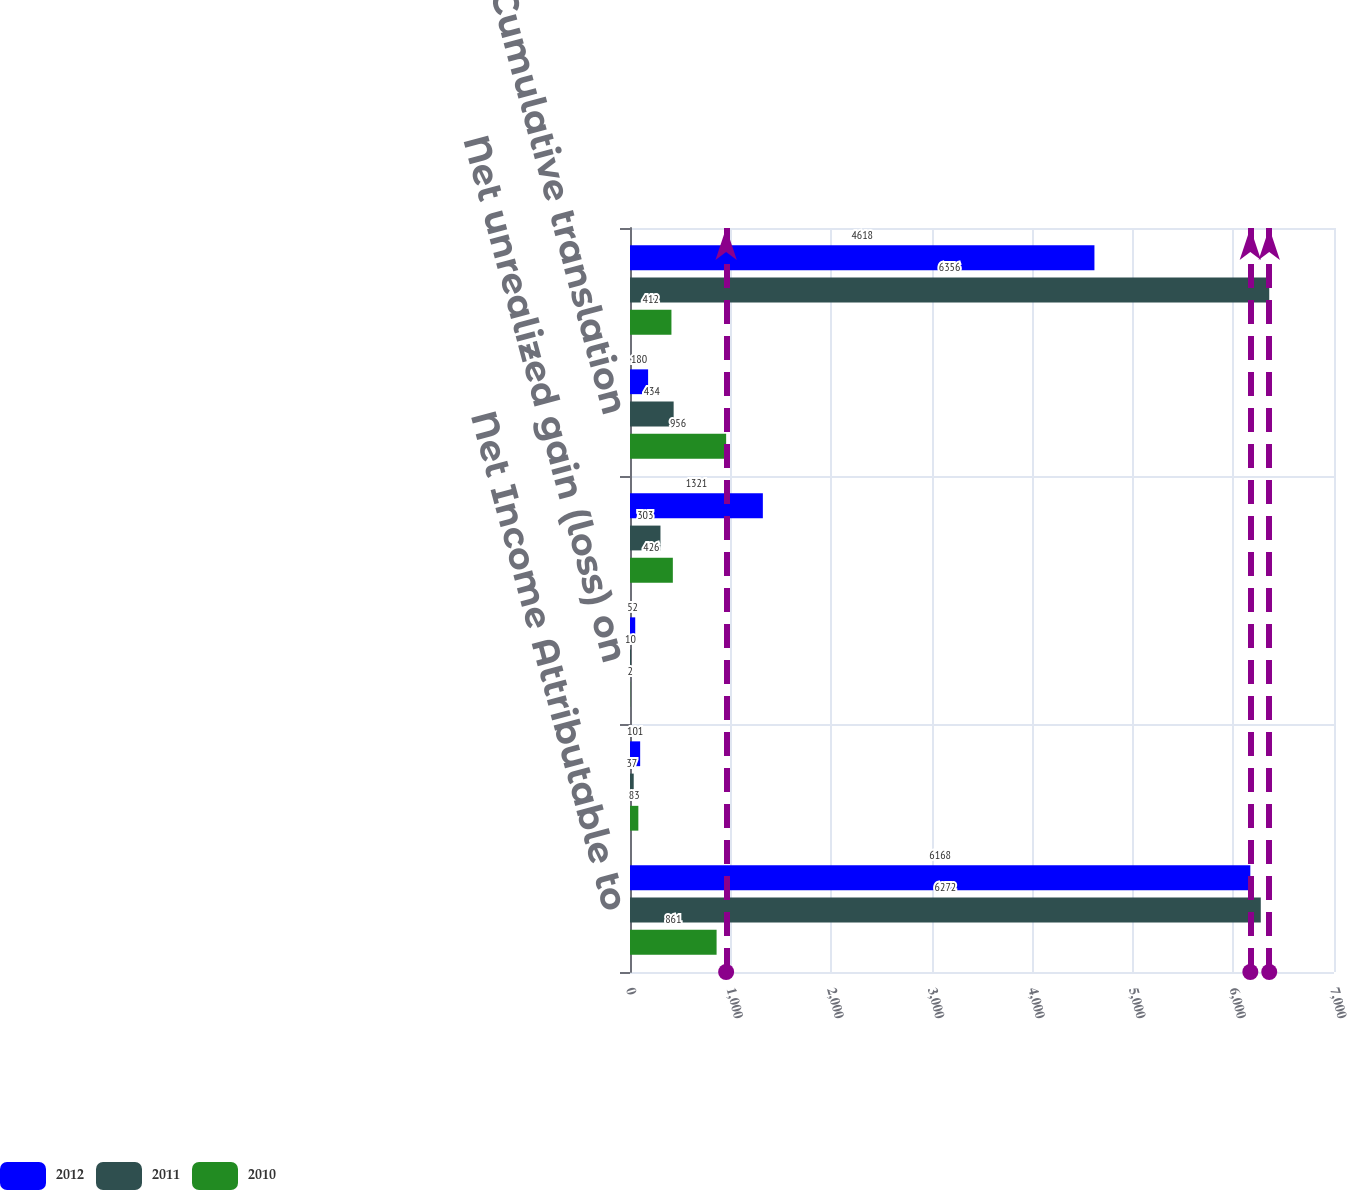Convert chart to OTSL. <chart><loc_0><loc_0><loc_500><loc_500><stacked_bar_chart><ecel><fcel>Net Income Attributable to<fcel>Net unrealized (loss) gain on<fcel>Net unrealized gain (loss) on<fcel>Benefit plan net (loss) gain<fcel>Cumulative translation<fcel>Comprehensive Income<nl><fcel>2012<fcel>6168<fcel>101<fcel>52<fcel>1321<fcel>180<fcel>4618<nl><fcel>2011<fcel>6272<fcel>37<fcel>10<fcel>303<fcel>434<fcel>6356<nl><fcel>2010<fcel>861<fcel>83<fcel>2<fcel>426<fcel>956<fcel>412<nl></chart> 